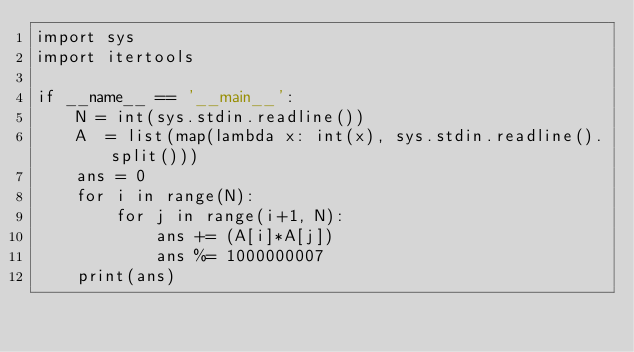Convert code to text. <code><loc_0><loc_0><loc_500><loc_500><_Python_>import sys
import itertools

if __name__ == '__main__':
    N = int(sys.stdin.readline())
    A  = list(map(lambda x: int(x), sys.stdin.readline().split()))
    ans = 0
    for i in range(N):
        for j in range(i+1, N):
            ans += (A[i]*A[j])
            ans %= 1000000007
    print(ans)</code> 